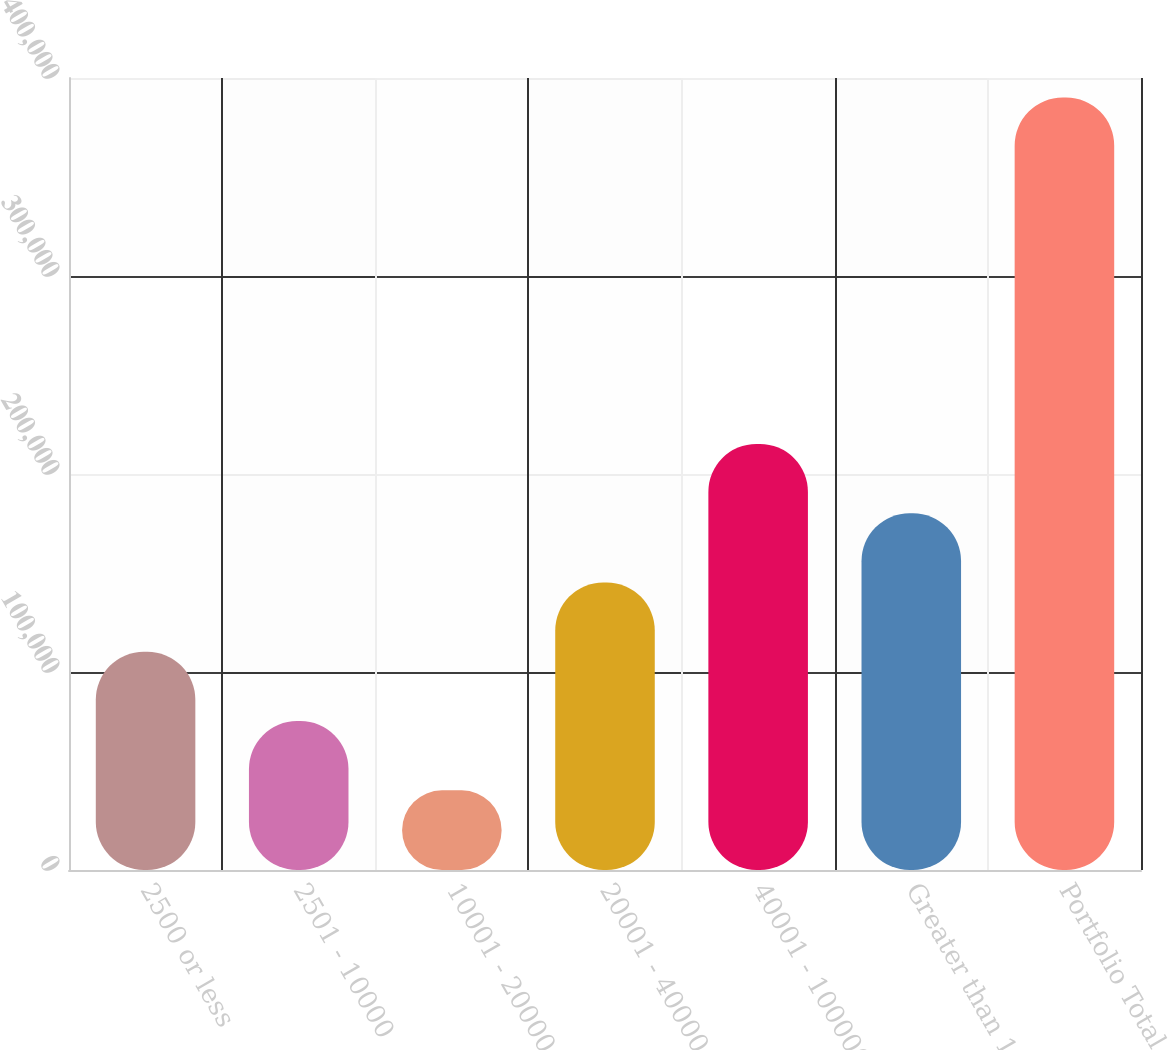Convert chart to OTSL. <chart><loc_0><loc_0><loc_500><loc_500><bar_chart><fcel>2500 or less<fcel>2501 - 10000<fcel>10001 - 20000<fcel>20001 - 40000<fcel>40001 - 100000<fcel>Greater than 100000<fcel>Portfolio Total<nl><fcel>110206<fcel>75215<fcel>40224<fcel>145197<fcel>215179<fcel>180188<fcel>390134<nl></chart> 